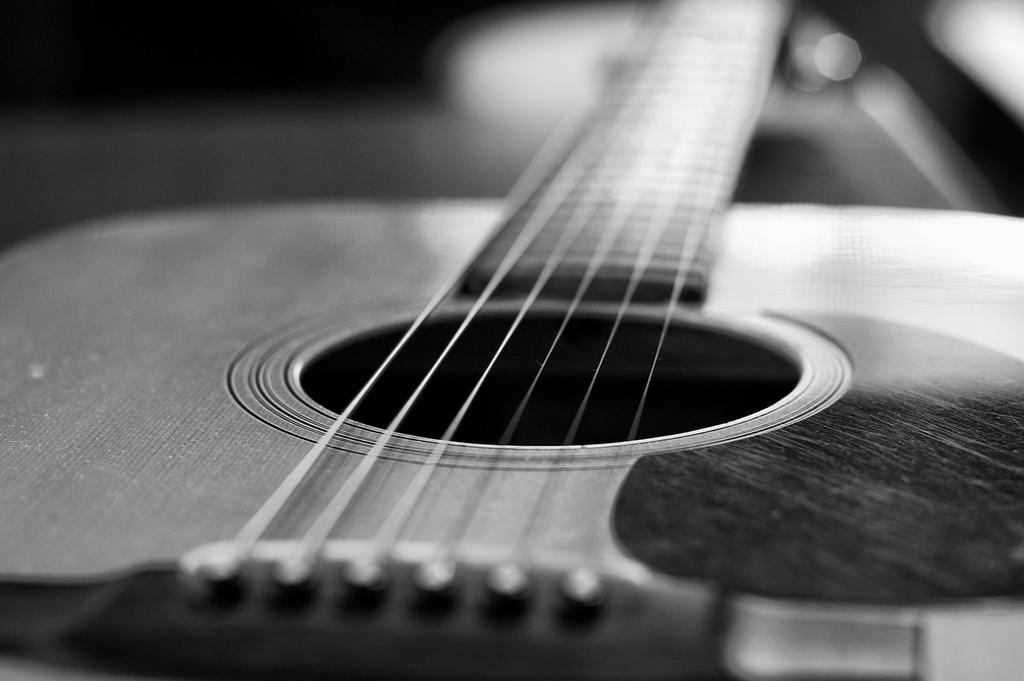What musical instrument is present in the image? There is a guitar in the image. Where is the guitar located? The guitar is on a table. What color scheme is used in the image? The image is in black and white color. What type of oil can be seen dripping from the guitar in the image? There is no oil present in the image, and the guitar is not depicted as dripping anything. 